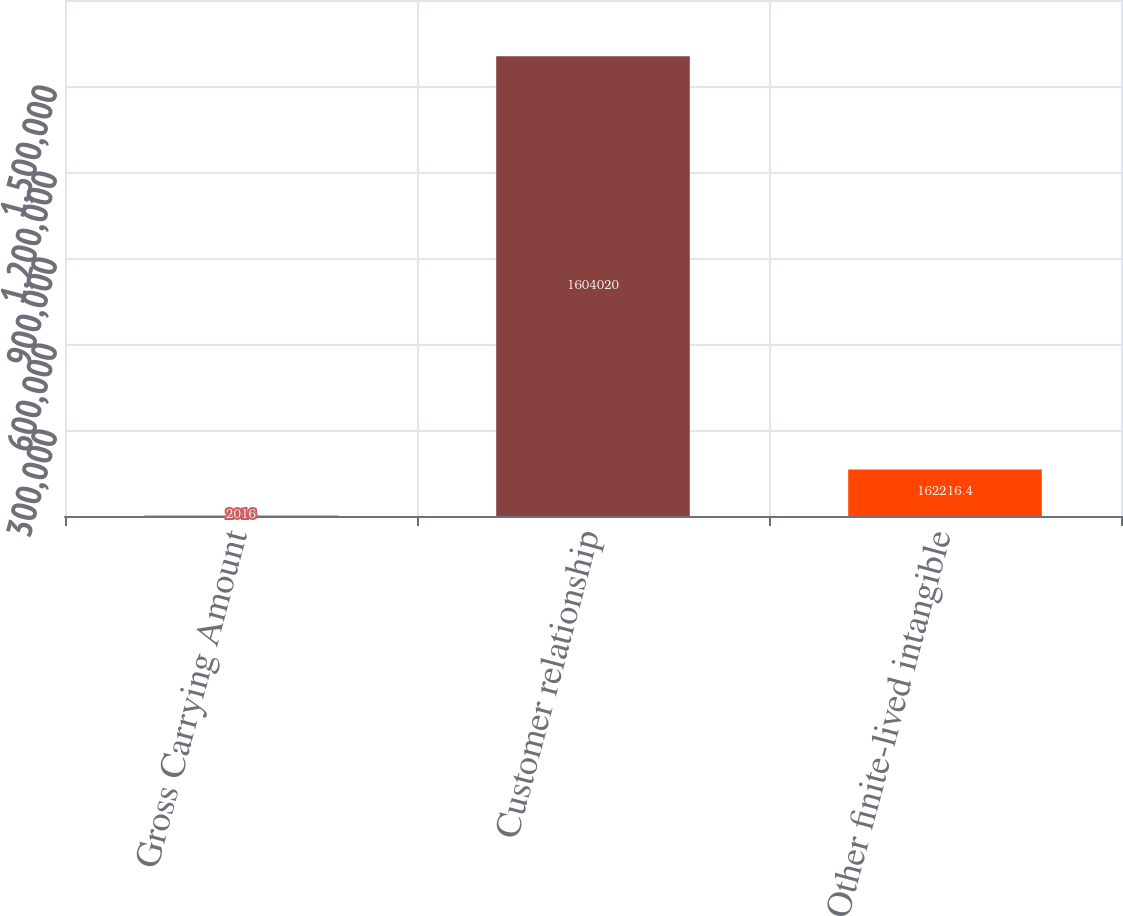Convert chart. <chart><loc_0><loc_0><loc_500><loc_500><bar_chart><fcel>Gross Carrying Amount<fcel>Customer relationship<fcel>Other finite-lived intangible<nl><fcel>2016<fcel>1.60402e+06<fcel>162216<nl></chart> 